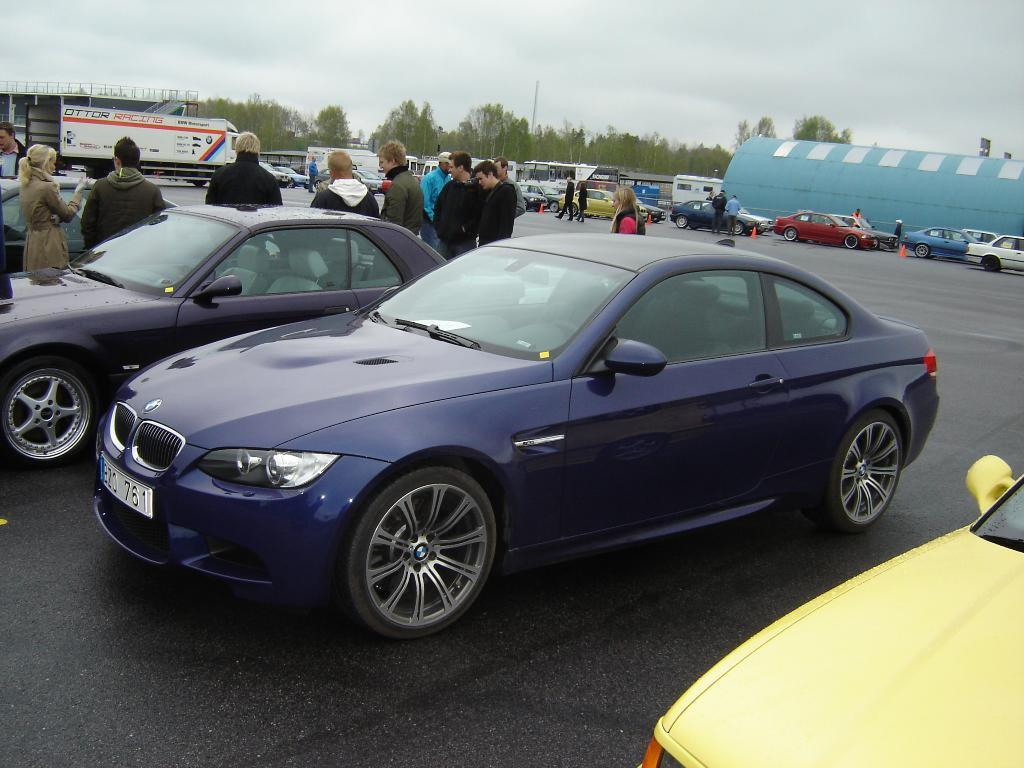What can be seen in the image related to transportation? There are vehicles in the image. Can you describe one of the vehicles in the image? One of the vehicles is blue. What is visible in the background of the image? There are people standing and trees with green color in the background. How would you describe the sky in the image? The sky appears to be white in color. Can you see any veins in the image? There are no veins visible in the image; it features vehicles, people, trees, and a sky. What type of paint is being used by the artist in the image? There is no artist or painting present in the image, so it's not possible to determine what type of paint is being used. 